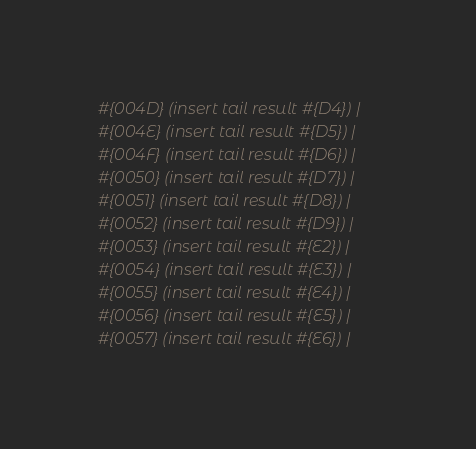Convert code to text. <code><loc_0><loc_0><loc_500><loc_500><_Ruby_>#{004D} (insert tail result #{D4}) | 
#{004E} (insert tail result #{D5}) | 
#{004F} (insert tail result #{D6}) | 
#{0050} (insert tail result #{D7}) | 
#{0051} (insert tail result #{D8}) | 
#{0052} (insert tail result #{D9}) | 
#{0053} (insert tail result #{E2}) | 
#{0054} (insert tail result #{E3}) | 
#{0055} (insert tail result #{E4}) | 
#{0056} (insert tail result #{E5}) | 
#{0057} (insert tail result #{E6}) | </code> 